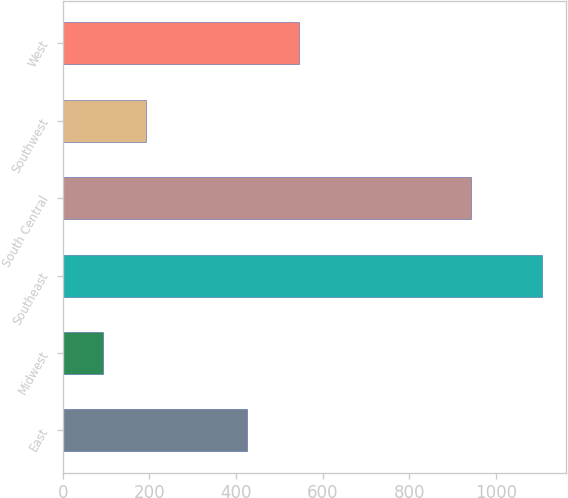Convert chart. <chart><loc_0><loc_0><loc_500><loc_500><bar_chart><fcel>East<fcel>Midwest<fcel>Southeast<fcel>South Central<fcel>Southwest<fcel>West<nl><fcel>425.4<fcel>91.6<fcel>1105.9<fcel>942.5<fcel>193.03<fcel>544.7<nl></chart> 